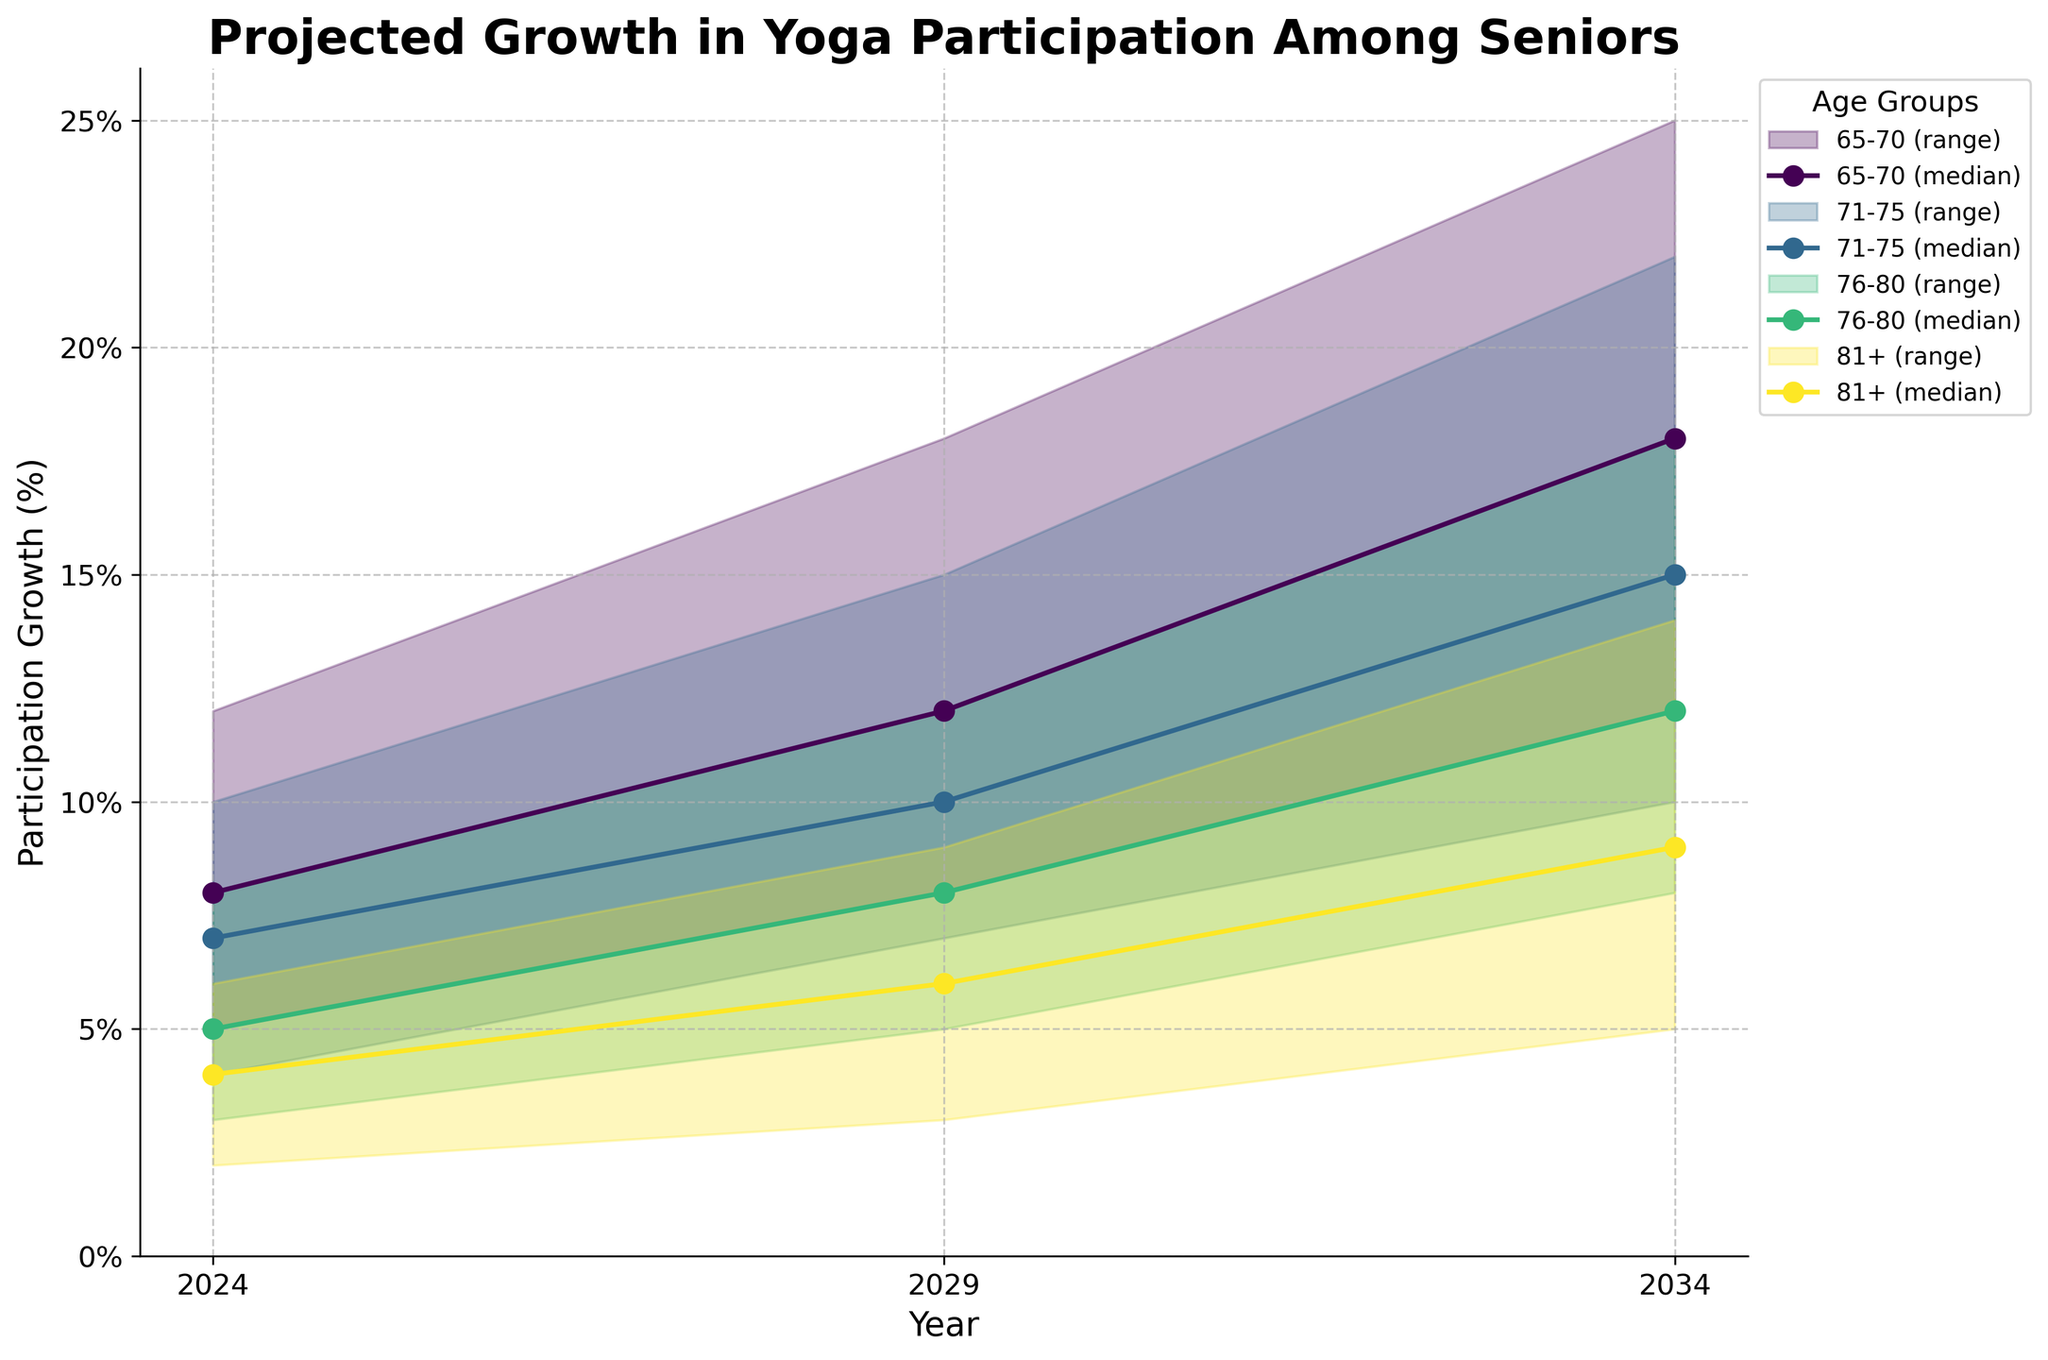What is the title of the figure? The title of the figure is displayed at the top and provides a summary of what the chart represents.
Answer: Projected Growth in Yoga Participation Among Seniors How many age groups are represented in the figure? By observing the legend or the different fill areas and lines, you can count the number of distinct age groups.
Answer: 4 Which age group is projected to have the highest median growth in yoga participation by 2034? Look at the end point (2034) of the median estimate lines for each age group. The line with the highest value indicates the age group with the highest median growth.
Answer: 65-70 What is the range of growth percentages for the 71-75 age group in 2029? Find the points corresponding to the year 2029 for the 71-75 age group and identify the low and high estimates to determine the range.
Answer: 7% to 15% Compare the projected median growth for the 76-80 age group between 2024 and 2029. Identify the median estimate points for the 76-80 age group in both years and calculate the difference.
Answer: 3% Which age group shows the least projected median growth increase from 2029 to 2034? Compare the difference in median values from 2029 to 2034 for all age groups and identify the smallest increase.
Answer: 81+ What is the projected high estimate of growth for the 65-70 age group in 2029? Locate the high estimate point for the 65-70 age group in the year 2029.
Answer: 18% How does the projected median growth for the 81+ age group change over the decade from 2024 to 2034? Identify the values of the median estimate for the 81+ age group in both years and calculate the change.
Answer: 5% Which age group shows the largest range of projected growth percentages in 2034? For each age group in 2034, calculate the difference between the high and low estimates and identify the largest one.
Answer: 65-70 Is the projected growth trend for the 71-75 age group generally increasing, decreasing, or stable from 2024 to 2034? Observe the trend of the median estimate line for the 71-75 age group across the years.
Answer: Increasing 